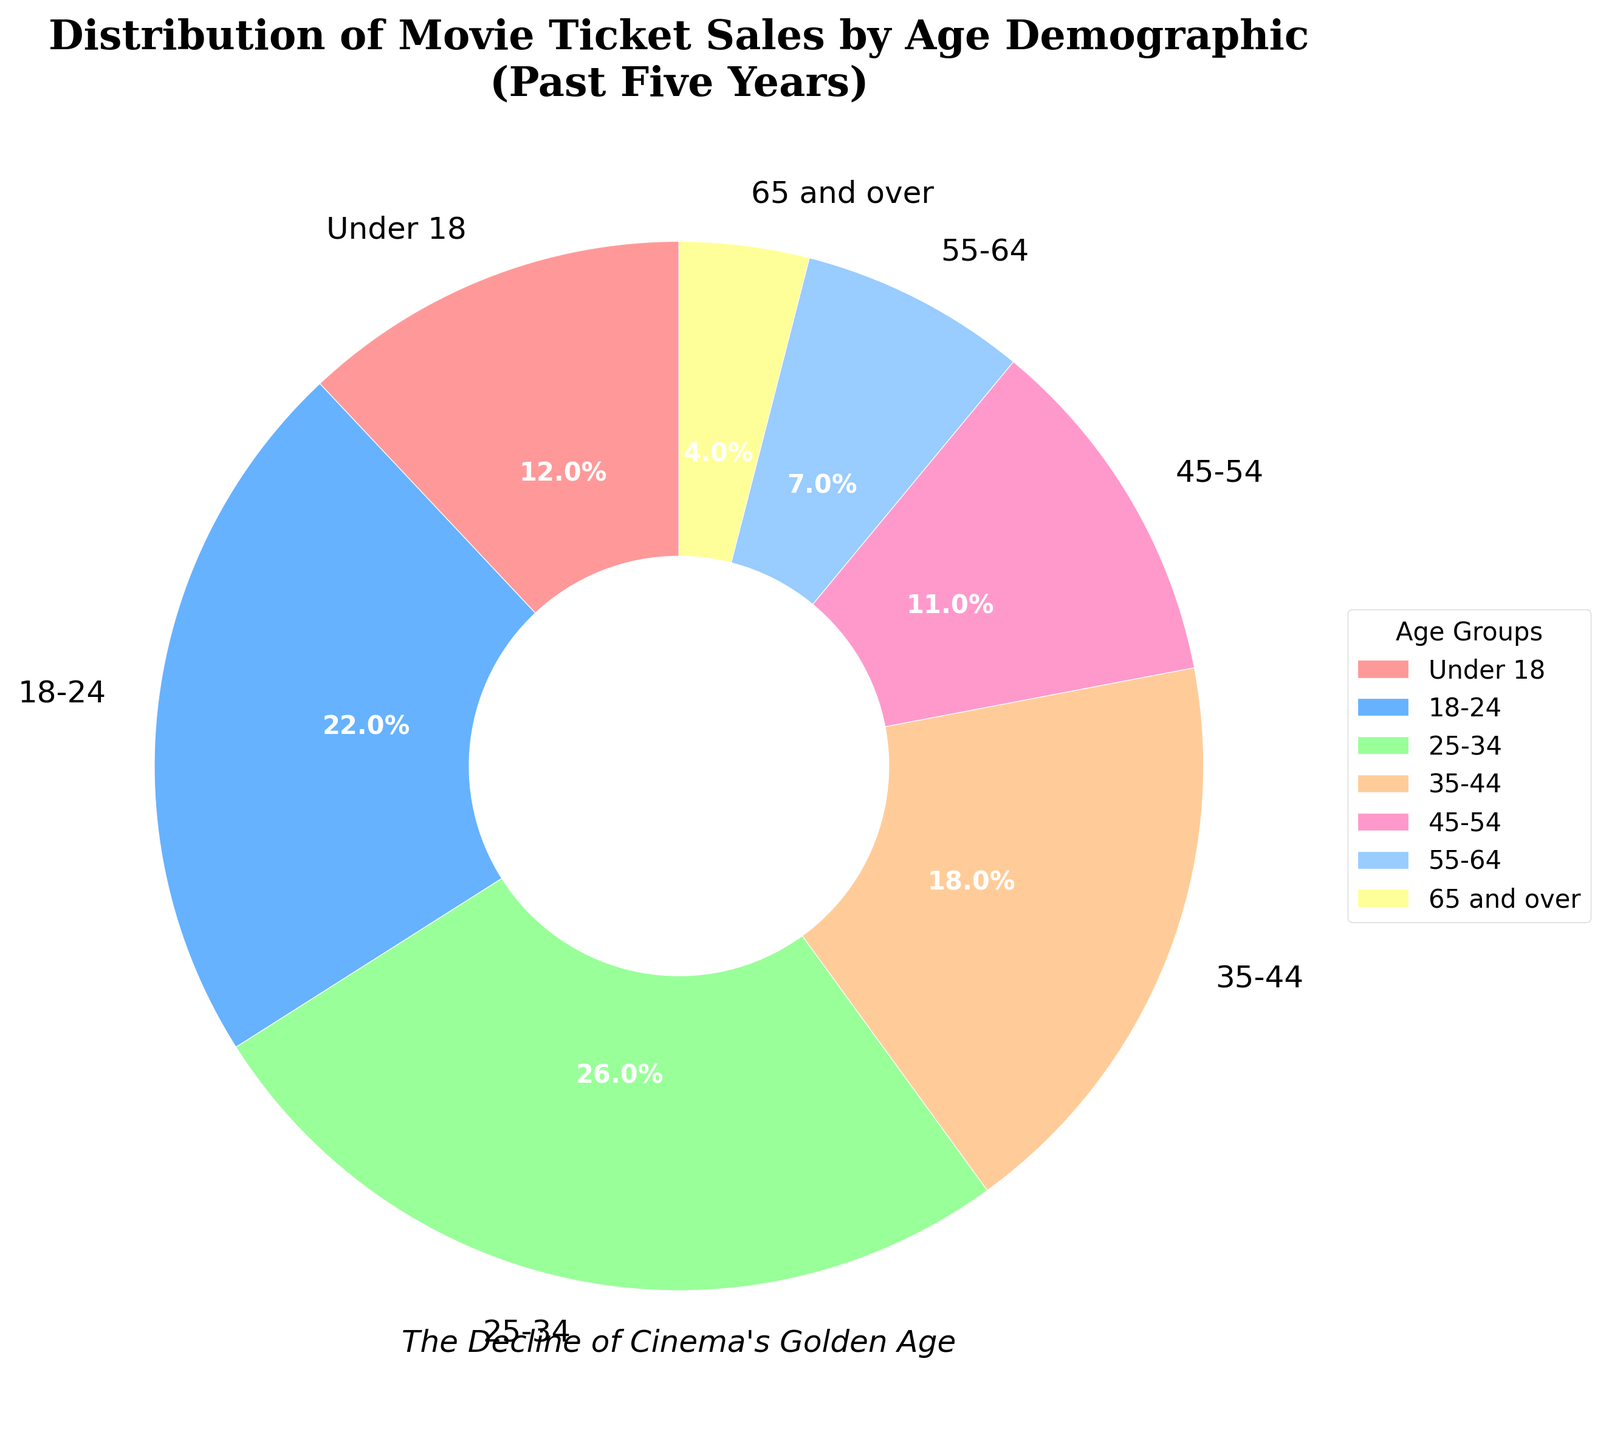What age group has the highest percentage of movie ticket sales? The highest percentage among the given age groups can be determined by comparing all the presented values. The 25-34 age group has the highest percentage at 26%.
Answer: 25-34 Which age group has a higher percentage of movie ticket sales, 18-24 or 35-44? By looking at the percentages next to each age group, we see that 18-24 has 22% and 35-44 has 18%. Therefore, 18-24 has a higher percentage.
Answer: 18-24 How much more percentage of movie ticket sales do the 25-34 age group have compared to the 55-64 age group? The percentage for the 25-34 age group is 26%, and for the 55-64 age group, it is 7%. The difference is 26% - 7% = 19%.
Answer: 19% What is the total percentage of movie ticket sales for viewers under 35 years old? To find the total percentage for viewers under 35, add the percentages of the under 18, 18-24, and 25-34 age groups: 12% + 22% + 26% = 60%.
Answer: 60% Which age group contributes the least to movie ticket sales? By examining the percentages, the 65 and over age group has the lowest percentage at 4%.
Answer: 65 and over How does the percentage of movie ticket sales for the 45-54 age group compare with the under 18 age group? The 45-54 age group has 11%, and the under-18 age group has 12%. The under-18 group has a slightly higher percentage than the 45-54 age group.
Answer: Under 18 If we add up the percentages for the two oldest age groups (55-64 and 65 and over), what is the total? Adding the percentages of the 55-64 and 65 and over age groups: 7% + 4% = 11%.
Answer: 11% Which age group has a percentage closest to 20%? The 18-24 age group has a percentage of 22%, which is closest to 20%.
Answer: 18-24 What is the difference in movie ticket sales percentage between the 35-44 age group and the 45-54 age group? The 35-44 age group has 18%, and the 45-54 age group has 11%. The difference is 18% - 11% = 7%.
Answer: 7% How much greater is the movie ticket sales percentage of the 25-34 age group compared to the combined percentage of the 55-64 and 65 and over age groups? The percentage for the 25-34 age group is 26%, and the combined percentage for the 55-64 and 65 and over age groups is 7% + 4% = 11%. The difference is 26% - 11% = 15%.
Answer: 15% 